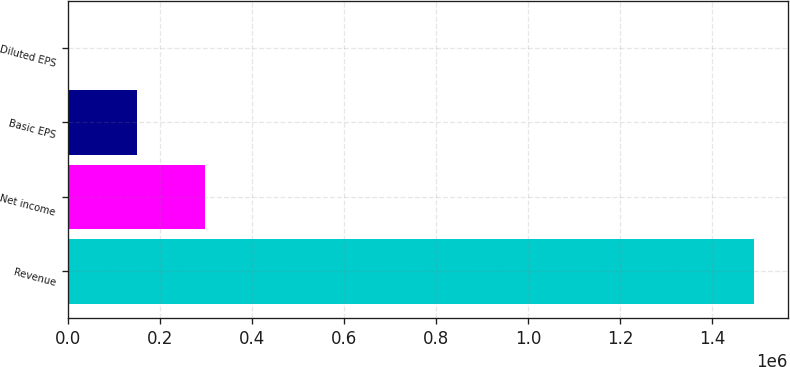Convert chart. <chart><loc_0><loc_0><loc_500><loc_500><bar_chart><fcel>Revenue<fcel>Net income<fcel>Basic EPS<fcel>Diluted EPS<nl><fcel>1.49096e+06<fcel>298193<fcel>149097<fcel>1.1<nl></chart> 